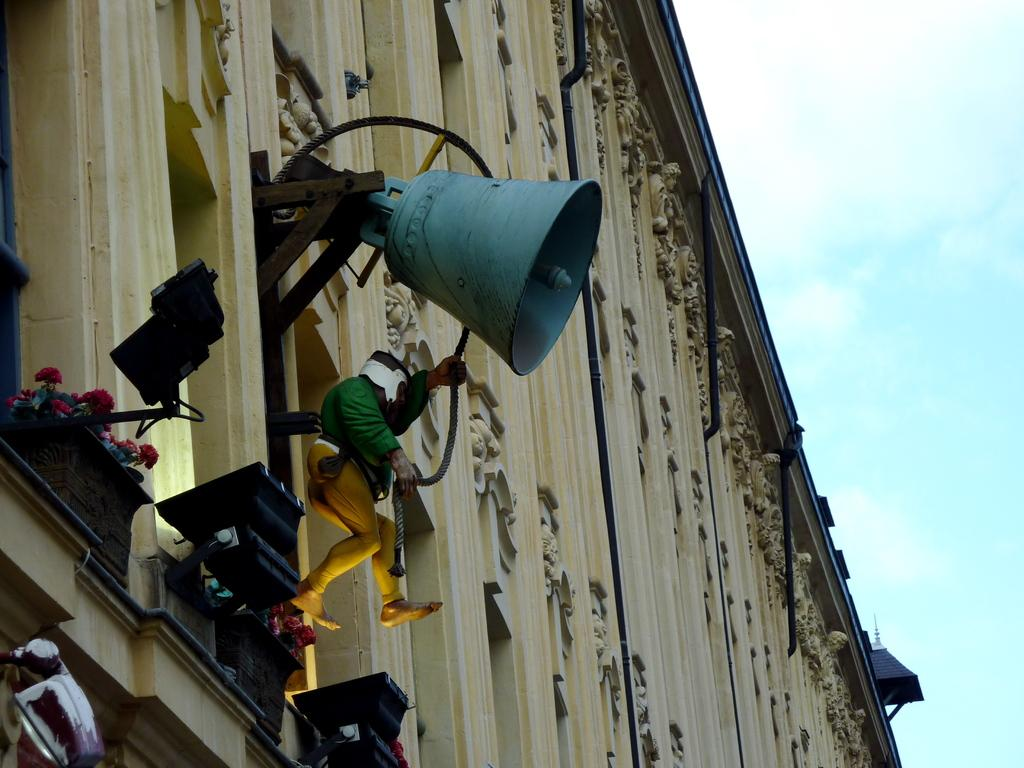What is the person in the image holding? The person is holding a rope in the image. What object is associated with the rope? There is a bell in the image. What can be seen illuminated in the image? There are lights in the image. What type of vegetation is present in the image? There are flowers in the image. What type of structure is visible in the image? There is a building in the image. What is visible in the background of the image? The sky is visible in the background of the image. What color is the writer's pen in the image? There is no writer or pen present in the image. How does the person holding the rope sneeze in the image? The person holding the rope does not sneeze in the image. 